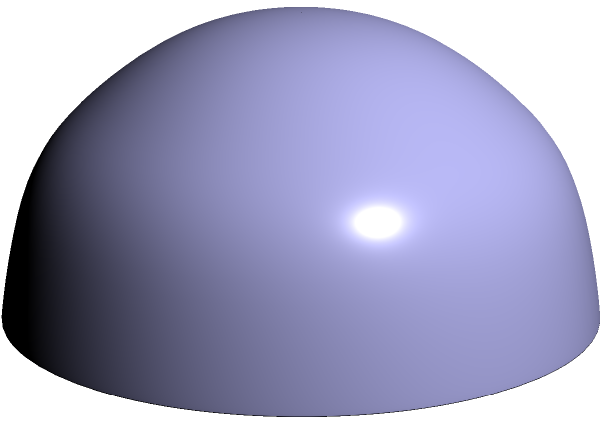On a unit sphere, points A(1,0,0) and B(0,1,0) represent two critical healthcare facilities. The geodesic (shortest path) between these points is shown in red. If this path represents the most efficient route for resource allocation, what is the length of this geodesic in radians? To find the length of the geodesic between points A and B on a unit sphere, we can follow these steps:

1. Recall that on a unit sphere, the length of a geodesic is equal to the angle it subtends at the center, measured in radians.

2. The angle between two vectors from the origin to points on a unit sphere is given by the arc cosine of their dot product.

3. Let's calculate the dot product of vectors OA and OB:
   $OA = (1,0,0)$
   $OB = (0,1,0)$
   $OA \cdot OB = 1(0) + 0(1) + 0(0) = 0$

4. Now, we can find the angle θ:
   $\theta = \arccos(OA \cdot OB) = \arccos(0)$

5. We know that $\arccos(0) = \frac{\pi}{2}$ radians or 90 degrees.

Therefore, the length of the geodesic between A and B on the unit sphere is $\frac{\pi}{2}$ radians.

This represents the most efficient path for resource allocation between the two healthcare facilities in this spherical model.
Answer: $\frac{\pi}{2}$ radians 